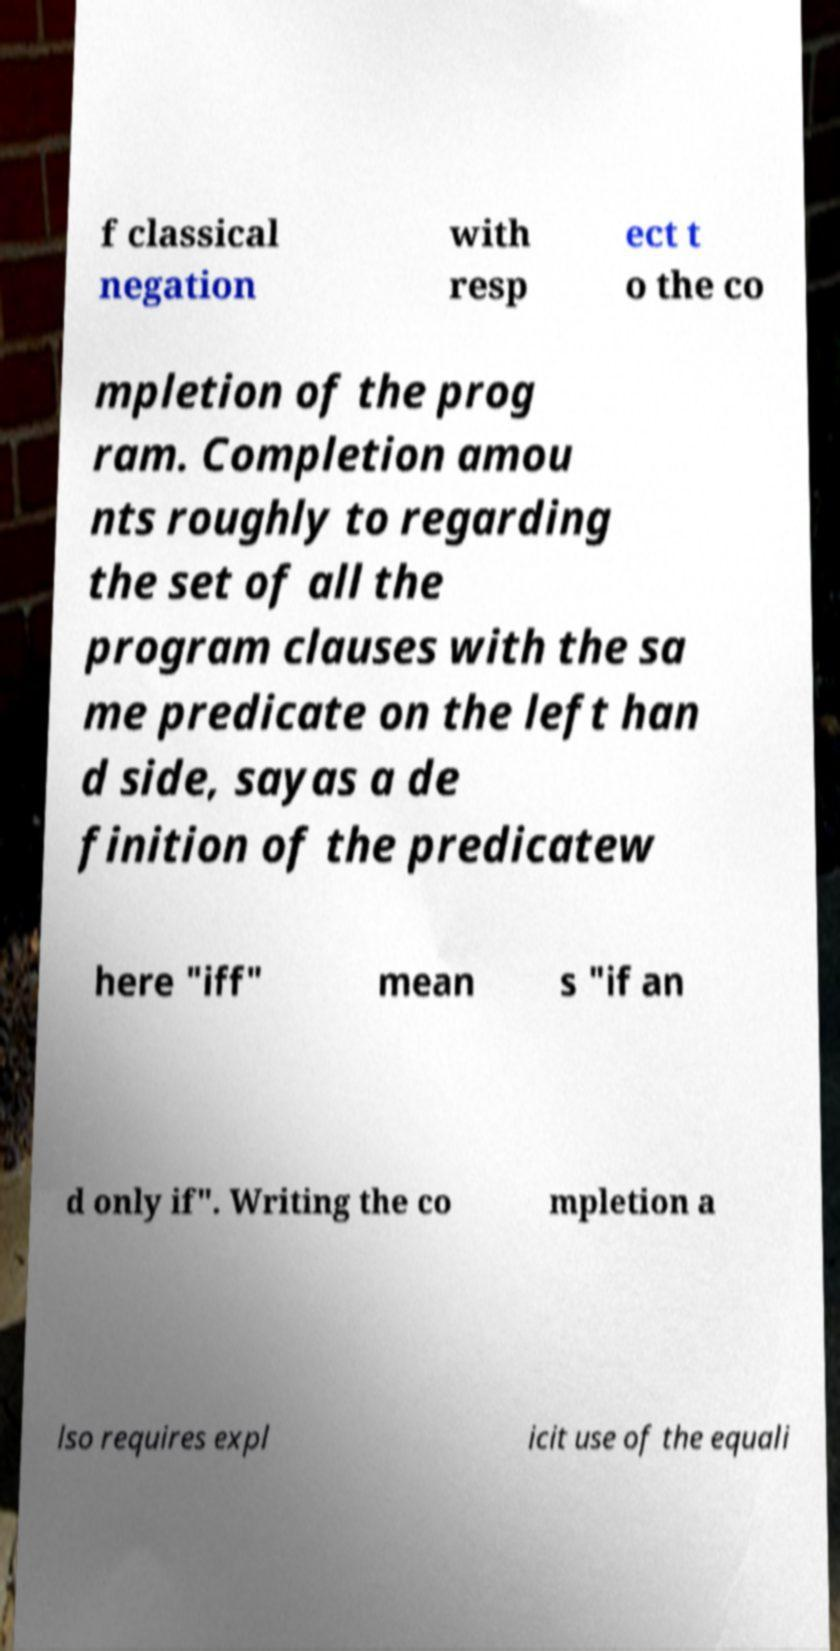Could you assist in decoding the text presented in this image and type it out clearly? f classical negation with resp ect t o the co mpletion of the prog ram. Completion amou nts roughly to regarding the set of all the program clauses with the sa me predicate on the left han d side, sayas a de finition of the predicatew here "iff" mean s "if an d only if". Writing the co mpletion a lso requires expl icit use of the equali 